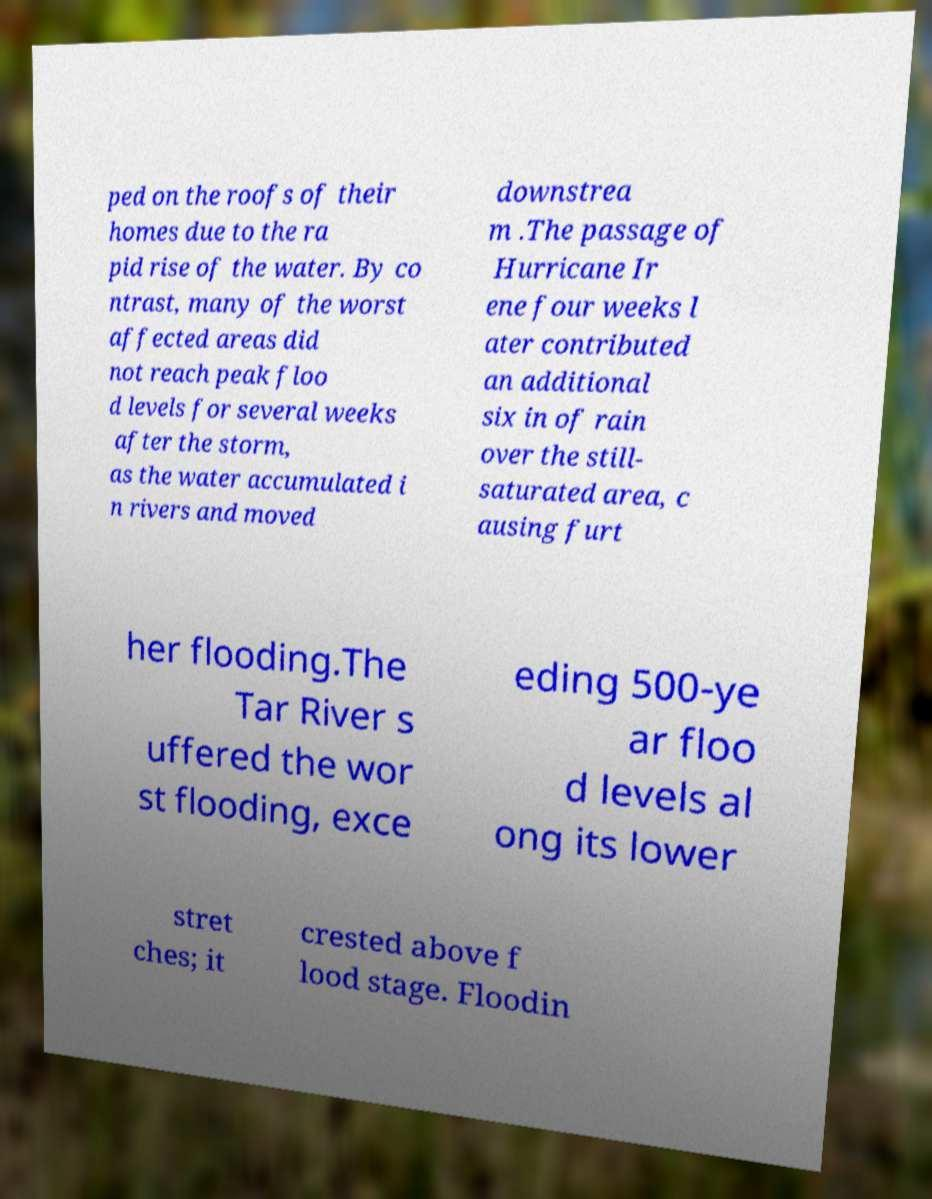Can you read and provide the text displayed in the image?This photo seems to have some interesting text. Can you extract and type it out for me? ped on the roofs of their homes due to the ra pid rise of the water. By co ntrast, many of the worst affected areas did not reach peak floo d levels for several weeks after the storm, as the water accumulated i n rivers and moved downstrea m .The passage of Hurricane Ir ene four weeks l ater contributed an additional six in of rain over the still- saturated area, c ausing furt her flooding.The Tar River s uffered the wor st flooding, exce eding 500-ye ar floo d levels al ong its lower stret ches; it crested above f lood stage. Floodin 